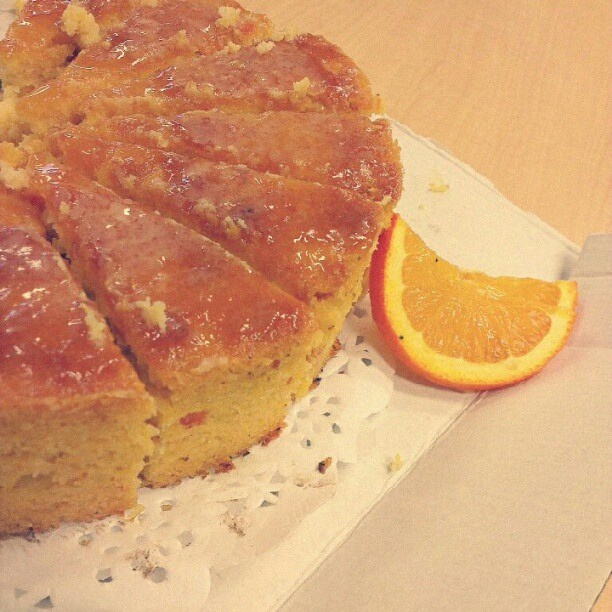Describe the objects in this image and their specific colors. I can see dining table in tan, red, and salmon tones, cake in tan, red, salmon, and brown tones, and orange in tan, orange, gold, and red tones in this image. 